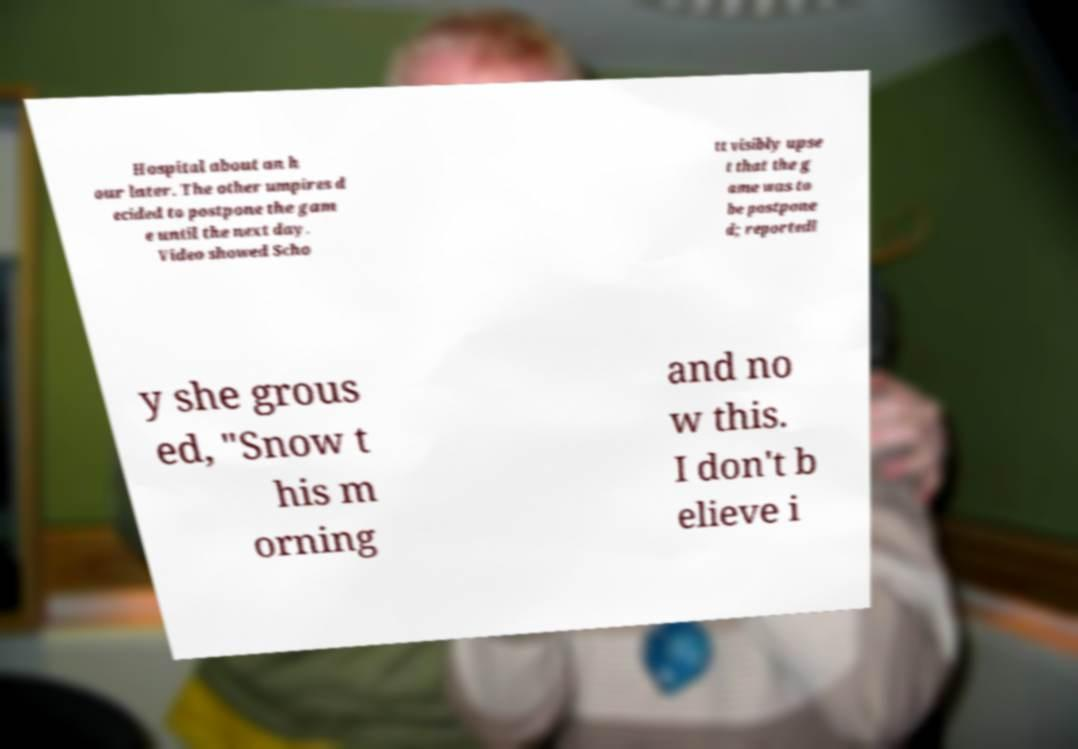I need the written content from this picture converted into text. Can you do that? Hospital about an h our later. The other umpires d ecided to postpone the gam e until the next day. Video showed Scho tt visibly upse t that the g ame was to be postpone d; reportedl y she grous ed, "Snow t his m orning and no w this. I don't b elieve i 